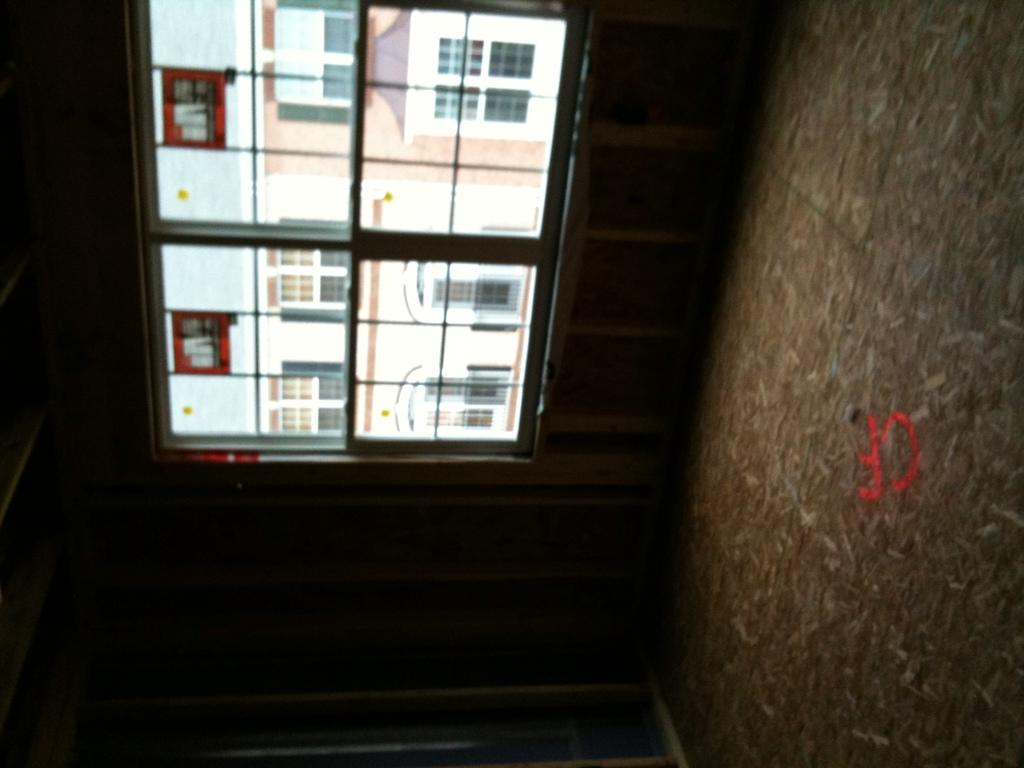What is located in the center of the image? There is a window in the center of the image. What can be seen on the right side of the image? There is a wall on the right side of the image. What type of cheese is being used to clean the soap in the image? There is no cheese or soap present in the image. In which direction is the window facing in the image? The provided facts do not specify the direction the window is facing, so it cannot be determined from the image. 